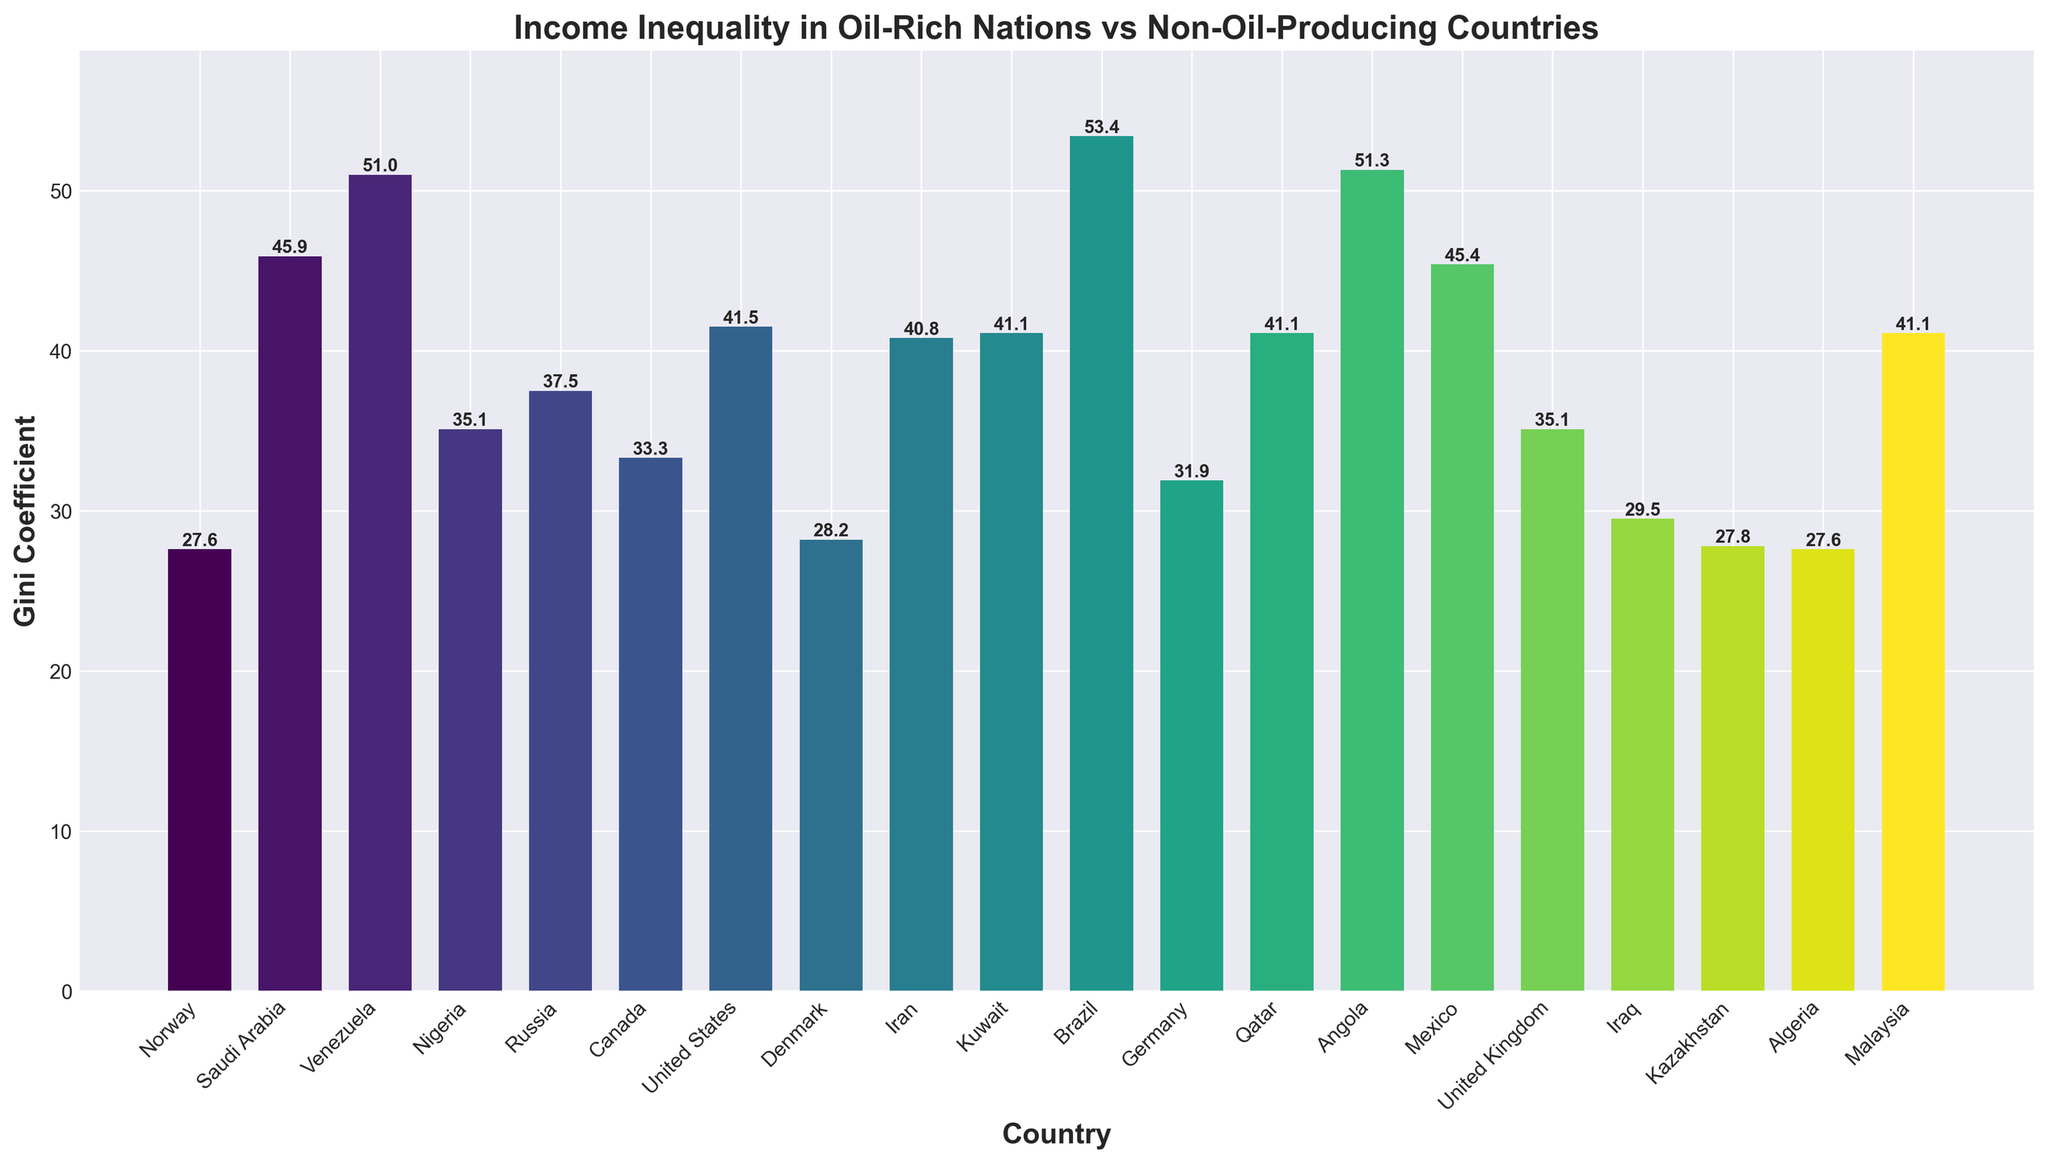Which country has the lowest Gini Coefficient? Identify the bar with the smallest height. The lowest Gini Coefficient is associated with Norway at 27.6
Answer: Norway Which country has the highest Gini Coefficient? Identify the bar with the greatest height. The highest Gini Coefficient is associated with Angola at 51.3
Answer: Angola How does the Gini Coefficient of Norway compare to that of Venezuela? Compare the heights of the bars for Norway and Venezuela. Norway has a Gini Coefficient of 27.6, and Venezuela has a Gini Coefficient of 51.0. Therefore, Norway has a significantly lower Gini Coefficient than Venezuela
Answer: Norway is lower What's the average Gini Coefficient of the oil-rich countries listed? Calculate the average. The oil-rich countries listed are Saudi Arabia, Venezuela, Nigeria, Russia, Iran, Kuwait, Qatar, Angola, Iraq, Kazakhstan, and Algeria with respective Gini Coefficients of 45.9, 51.0, 35.1, 37.5, 40.8, 41.1, 41.1, 51.3, 29.5, 27.8, and 27.6. Sum these values (46 + 51 + 35.1 + 37.5 + 40.8 + 41.1 + 41.1+ 51.3 + 29.5 + 27.8 + 27.6) gives 429.2. Dividing by 11 gives approximately 39.0
Answer: 39.0 What is the difference in the Gini Coefficient between the United States and Canada? Subtract Canada's Gini Coefficient from that of the United States. Canada's Gini Coefficient is 33.3 and the United States' is 41.5, so 41.5 - 33.3 = 8.2
Answer: 8.2 Which non-oil-producing country has the highest Gini Coefficient and how does it compare to the highest one among oil-rich countries? Identify the highest non-oil-producing country first. Brazil has the highest Gini Coefficient among non-oil-producing countries with 53.4. Compare it to the highest among oil-rich countries, which is Angola at 51.3. Brazil's Gini Coefficient is higher.
Answer: Brazil has 53.4 and Angola has 51.3 What's the range of Gini Coefficients among the oil-rich countries? Subtract the lowest Gini Coefficient value from the highest among oil-rich countries. The highest is 51.3 (Angola) and the lowest is 27.6 (Algeria), so the range is 51.3 - 27.6 = 23.7
Answer: 23.7 Are there more oil-rich countries with Gini Coefficients above 40 than below 40? Count the countries with Gini Coefficients above and below 40. There are 6 oil-rich countries with Gini Coefficients above 40 (Saudi Arabia, Iran, Kuwait, Qatar, Venezuela, and Angola) and 5 below 40 (Nigeria, Russia, Iraq, Kazakhstan, and Algeria). So yes, there are more above 40 than below.
Answer: Yes, 6 vs 5 